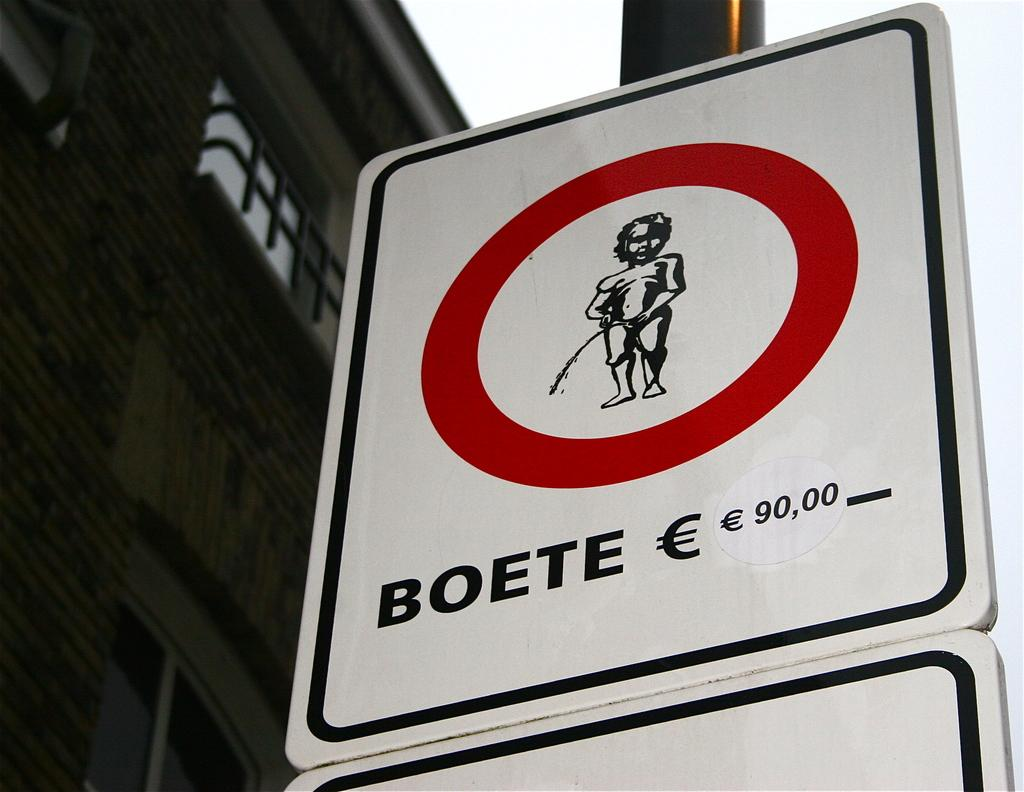<image>
Describe the image concisely. A sign that warns you that there will be a 90,000 fine from Boete. 